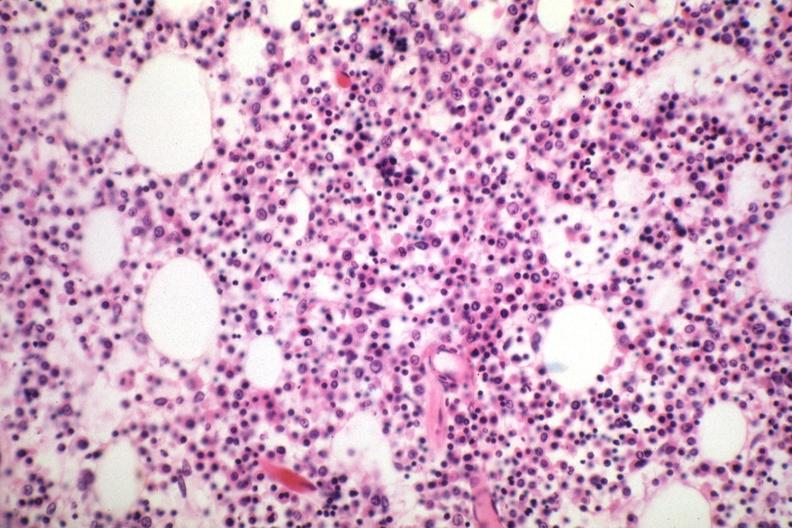does this image show marrow loaded with plasma cells that are immature?
Answer the question using a single word or phrase. Yes 